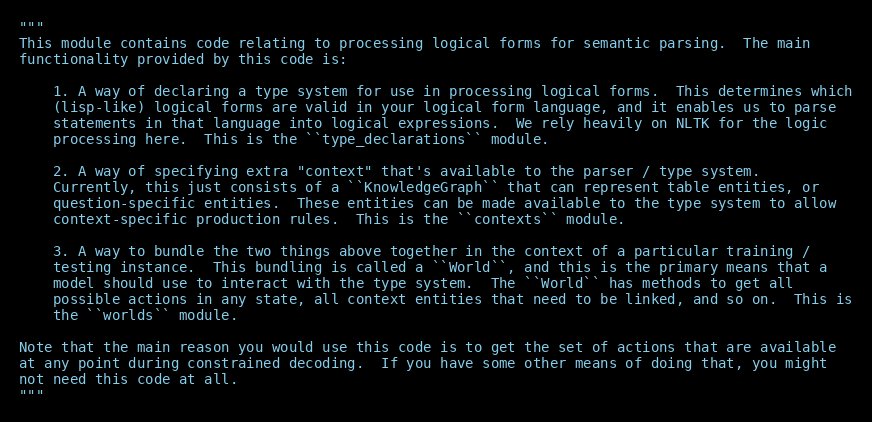Convert code to text. <code><loc_0><loc_0><loc_500><loc_500><_Python_>"""
This module contains code relating to processing logical forms for semantic parsing.  The main
functionality provided by this code is:

    1. A way of declaring a type system for use in processing logical forms.  This determines which
    (lisp-like) logical forms are valid in your logical form language, and it enables us to parse
    statements in that language into logical expressions.  We rely heavily on NLTK for the logic
    processing here.  This is the ``type_declarations`` module.

    2. A way of specifying extra "context" that's available to the parser / type system.
    Currently, this just consists of a ``KnowledgeGraph`` that can represent table entities, or
    question-specific entities.  These entities can be made available to the type system to allow
    context-specific production rules.  This is the ``contexts`` module.

    3. A way to bundle the two things above together in the context of a particular training /
    testing instance.  This bundling is called a ``World``, and this is the primary means that a
    model should use to interact with the type system.  The ``World`` has methods to get all
    possible actions in any state, all context entities that need to be linked, and so on.  This is
    the ``worlds`` module.

Note that the main reason you would use this code is to get the set of actions that are available
at any point during constrained decoding.  If you have some other means of doing that, you might
not need this code at all.
"""
</code> 